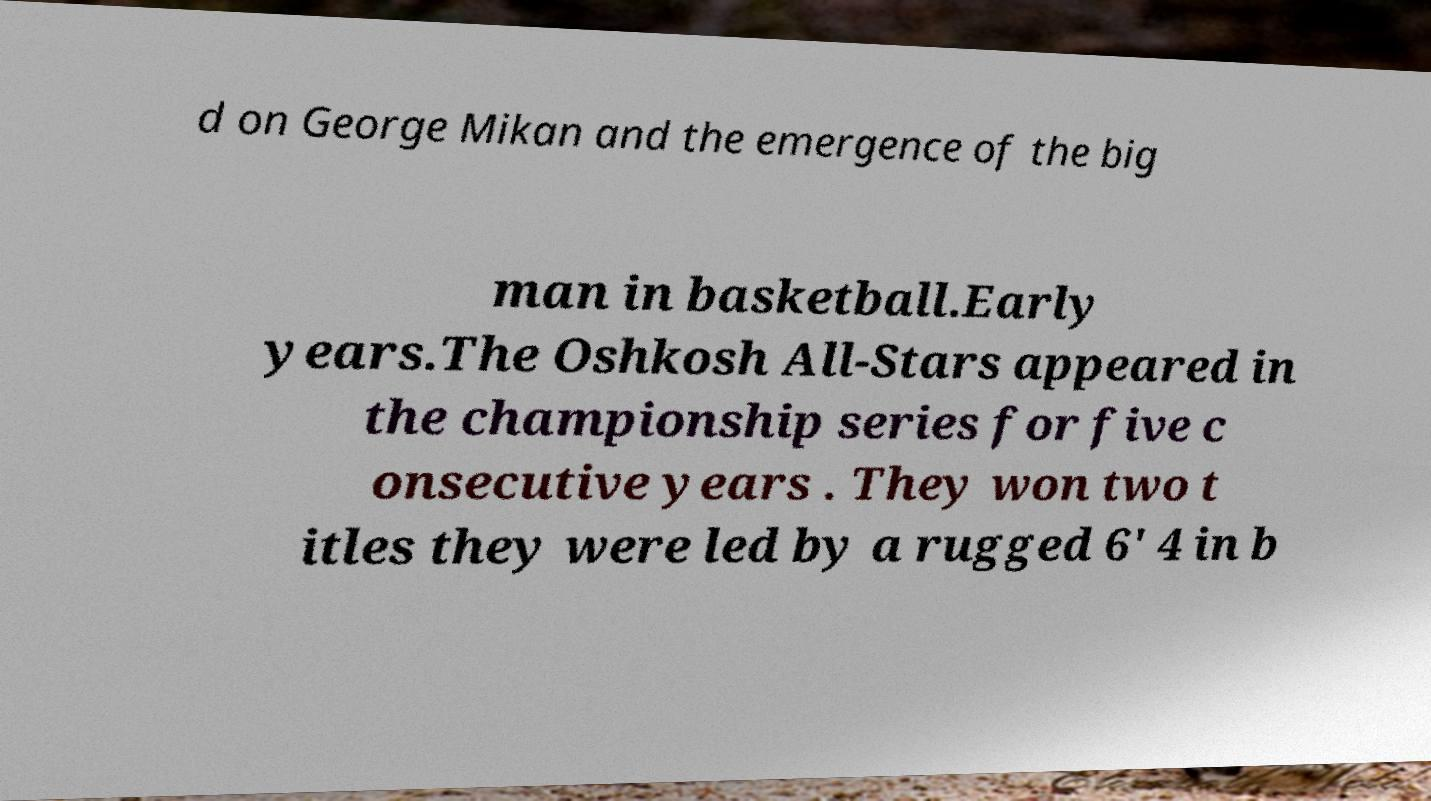Could you assist in decoding the text presented in this image and type it out clearly? d on George Mikan and the emergence of the big man in basketball.Early years.The Oshkosh All-Stars appeared in the championship series for five c onsecutive years . They won two t itles they were led by a rugged 6' 4 in b 